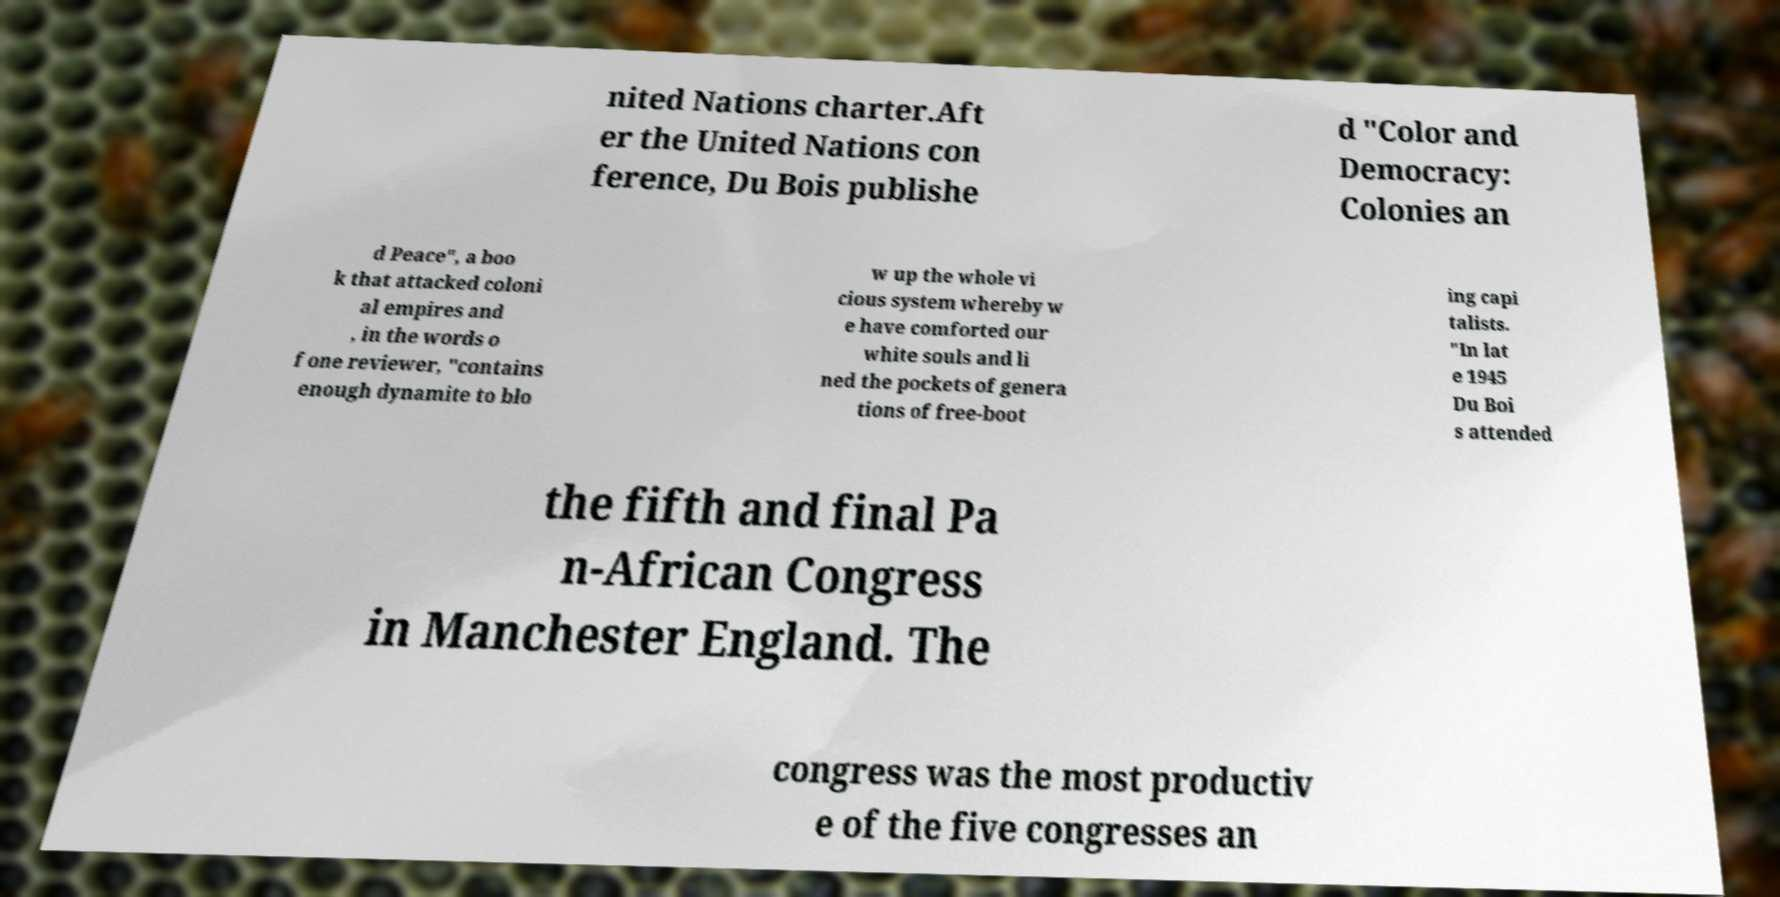Can you accurately transcribe the text from the provided image for me? nited Nations charter.Aft er the United Nations con ference, Du Bois publishe d "Color and Democracy: Colonies an d Peace", a boo k that attacked coloni al empires and , in the words o f one reviewer, "contains enough dynamite to blo w up the whole vi cious system whereby w e have comforted our white souls and li ned the pockets of genera tions of free-boot ing capi talists. "In lat e 1945 Du Boi s attended the fifth and final Pa n-African Congress in Manchester England. The congress was the most productiv e of the five congresses an 